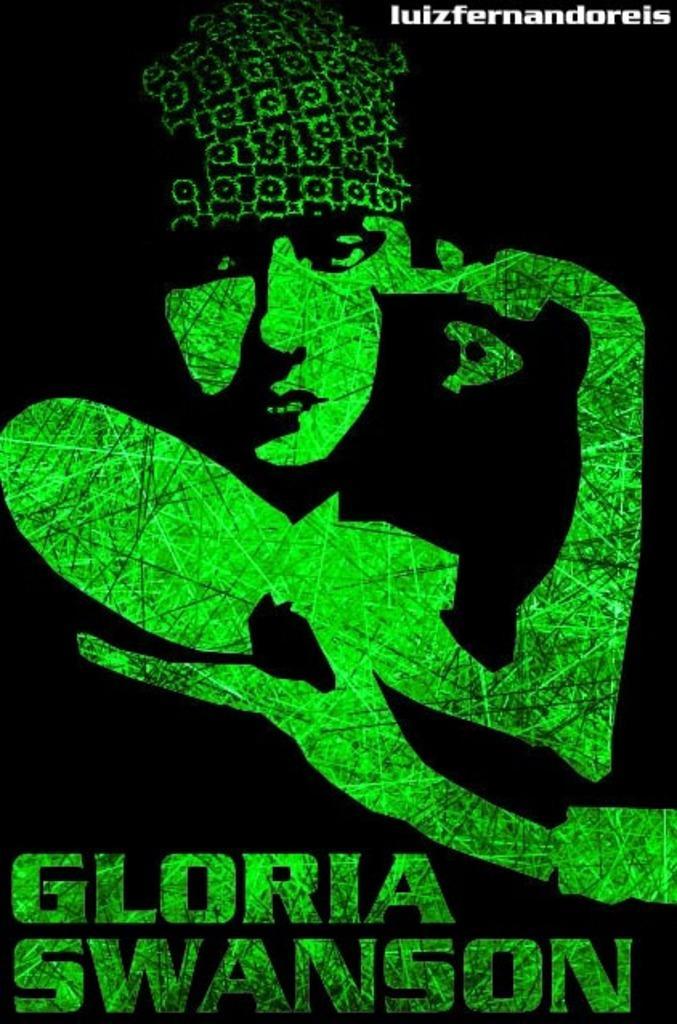Describe this image in one or two sentences. In this image I can see some art and some text is written on it and in the background we can see the black. 